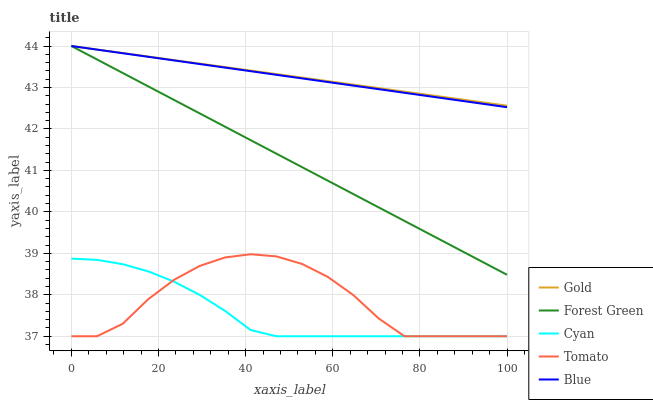Does Forest Green have the minimum area under the curve?
Answer yes or no. No. Does Forest Green have the maximum area under the curve?
Answer yes or no. No. Is Cyan the smoothest?
Answer yes or no. No. Is Cyan the roughest?
Answer yes or no. No. Does Forest Green have the lowest value?
Answer yes or no. No. Does Cyan have the highest value?
Answer yes or no. No. Is Tomato less than Gold?
Answer yes or no. Yes. Is Gold greater than Cyan?
Answer yes or no. Yes. Does Tomato intersect Gold?
Answer yes or no. No. 